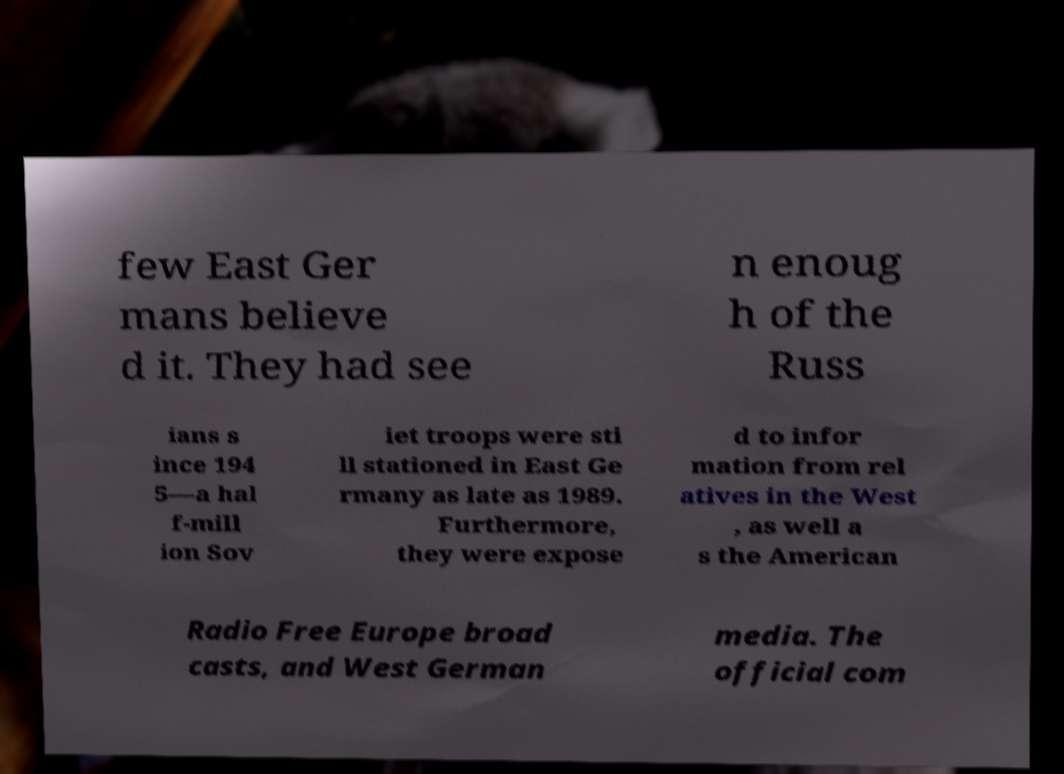Can you accurately transcribe the text from the provided image for me? few East Ger mans believe d it. They had see n enoug h of the Russ ians s ince 194 5—a hal f-mill ion Sov iet troops were sti ll stationed in East Ge rmany as late as 1989. Furthermore, they were expose d to infor mation from rel atives in the West , as well a s the American Radio Free Europe broad casts, and West German media. The official com 